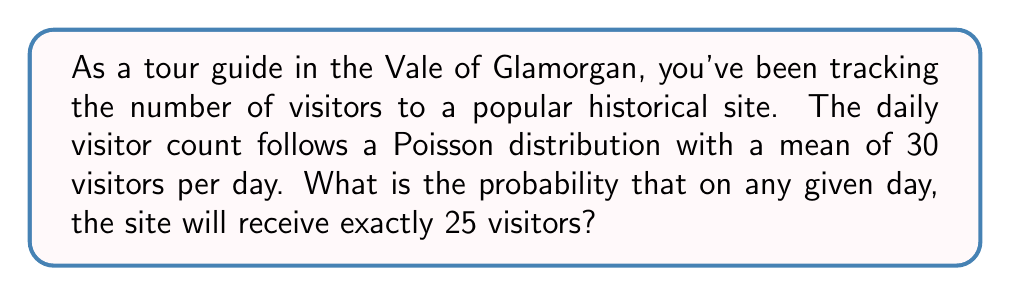Give your solution to this math problem. To solve this problem, we'll use the Poisson probability mass function:

$$P(X = k) = \frac{e^{-\lambda} \lambda^k}{k!}$$

Where:
$\lambda$ = mean number of visitors per day = 30
$k$ = number of visitors we're interested in = 25
$e$ = Euler's number ≈ 2.71828

Step 1: Substitute the values into the formula:
$$P(X = 25) = \frac{e^{-30} 30^{25}}{25!}$$

Step 2: Calculate $e^{-30}$:
$e^{-30} \approx 9.357623 \times 10^{-14}$

Step 3: Calculate $30^{25}$:
$30^{25} \approx 8.472930 \times 10^{36}$

Step 4: Calculate 25!:
$25! = 15511210043330985984000000$

Step 5: Put it all together:
$$P(X = 25) = \frac{(9.357623 \times 10^{-14})(8.472930 \times 10^{36})}{15511210043330985984000000}$$

Step 6: Simplify:
$$P(X = 25) \approx 0.0510$$

Therefore, the probability of exactly 25 visitors on any given day is approximately 0.0510 or 5.10%.
Answer: 0.0510 